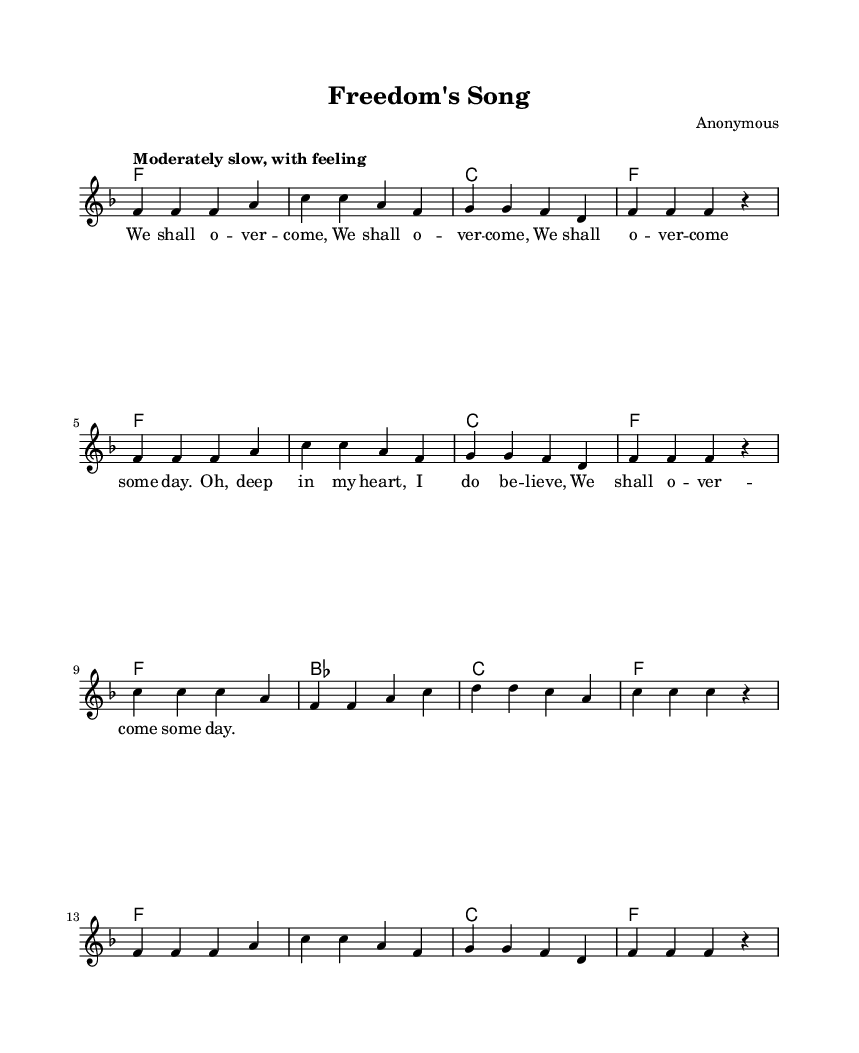What is the key signature of this music? The key signature is specified in the global block, and it is F major, which has one flat (B flat).
Answer: F major What is the time signature of this music? The time signature is indicated in the global block with "4/4", meaning there are four beats in each measure and the quarter note gets one beat.
Answer: 4/4 What is the tempo marking of this music? The tempo marking in the global block states "Moderately slow, with feeling," indicating the speed and expressiveness intended by the composer.
Answer: Moderately slow How many measures are in the melody? Counting each measure in the melody, it consists of a total of 12 measures throughout the piece.
Answer: 12 What is the first line of the lyrics? The lyrics provided in the text section start with "We shall o -- ver -- come, We shall o -- ver -- come," which signifies the message of hope and perseverance.
Answer: We shall o -- ver -- come Which chord is played for the first measure? The first measure contains the chord "F," which is the tonic chord in the key of F major and sets the foundation for the progression.
Answer: F What type of song is this sheet music representing? This sheet music represents a "Gospel" song, characterized by its themes of faith, hope, and communal struggle, aligning it with religious contexts.
Answer: Gospel 